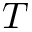<formula> <loc_0><loc_0><loc_500><loc_500>T</formula> 